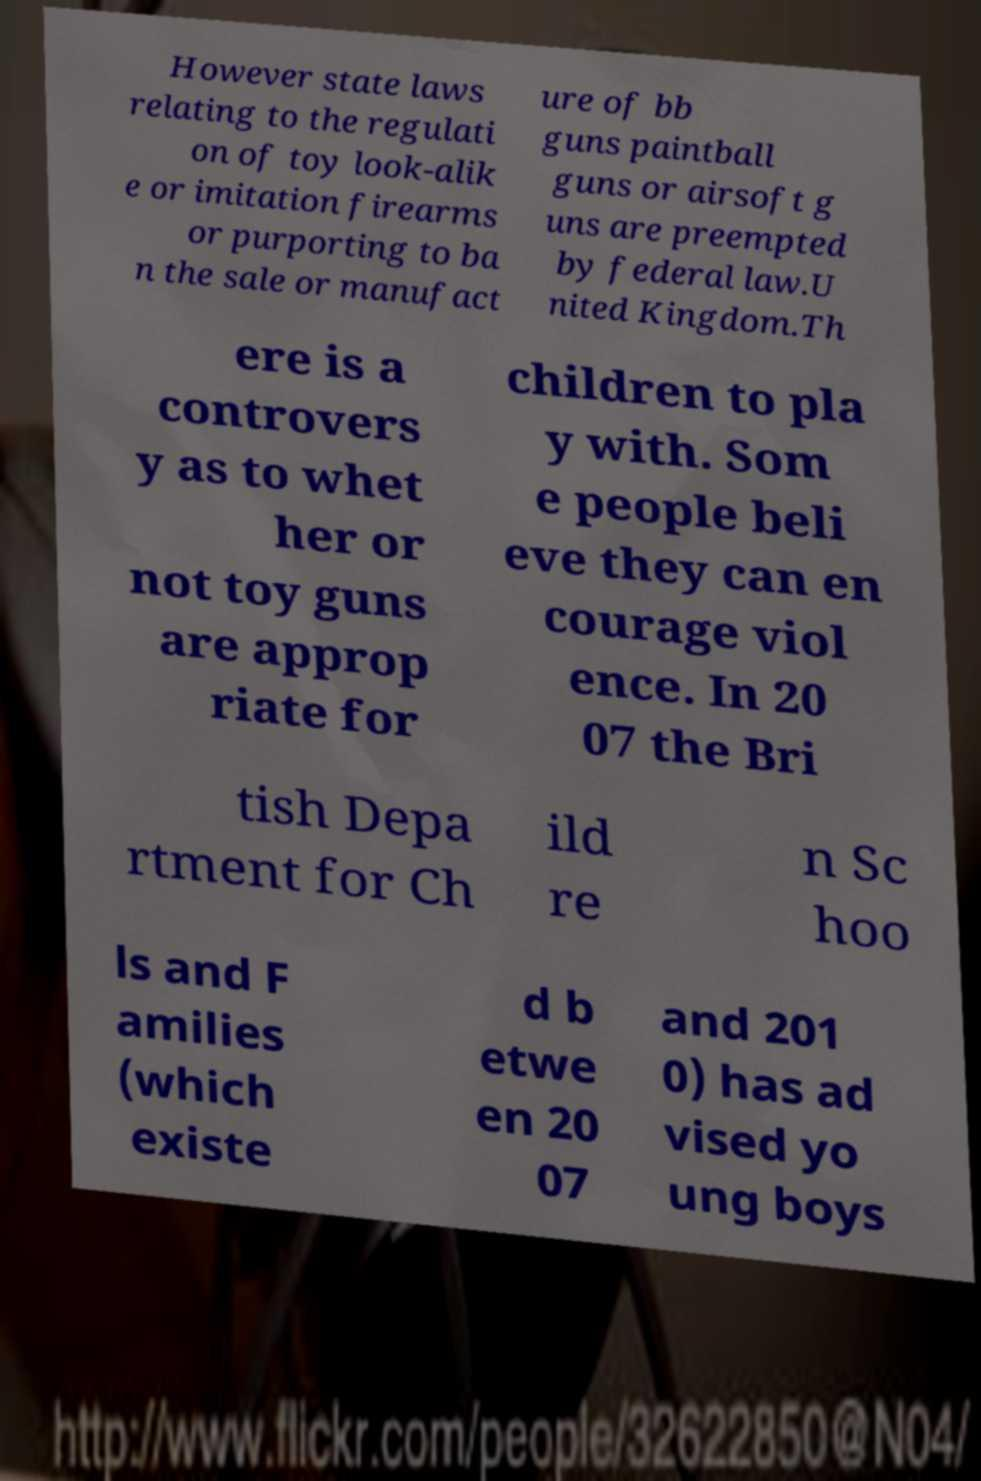Can you read and provide the text displayed in the image?This photo seems to have some interesting text. Can you extract and type it out for me? However state laws relating to the regulati on of toy look-alik e or imitation firearms or purporting to ba n the sale or manufact ure of bb guns paintball guns or airsoft g uns are preempted by federal law.U nited Kingdom.Th ere is a controvers y as to whet her or not toy guns are approp riate for children to pla y with. Som e people beli eve they can en courage viol ence. In 20 07 the Bri tish Depa rtment for Ch ild re n Sc hoo ls and F amilies (which existe d b etwe en 20 07 and 201 0) has ad vised yo ung boys 